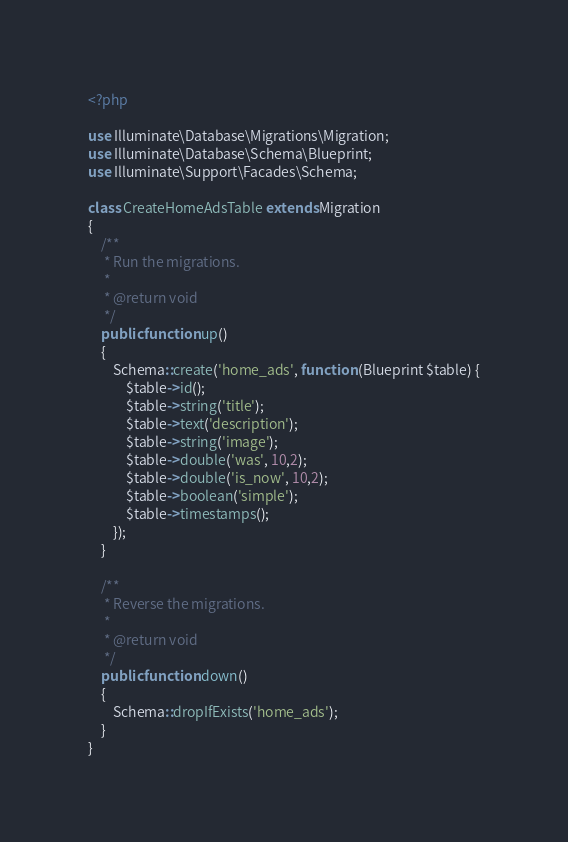Convert code to text. <code><loc_0><loc_0><loc_500><loc_500><_PHP_><?php

use Illuminate\Database\Migrations\Migration;
use Illuminate\Database\Schema\Blueprint;
use Illuminate\Support\Facades\Schema;

class CreateHomeAdsTable extends Migration
{
    /**
     * Run the migrations.
     *
     * @return void
     */
    public function up()
    {
        Schema::create('home_ads', function (Blueprint $table) {
            $table->id();
            $table->string('title');
            $table->text('description');
            $table->string('image');
            $table->double('was', 10,2);
            $table->double('is_now', 10,2);
            $table->boolean('simple');
            $table->timestamps();
        });
    }

    /**
     * Reverse the migrations.
     *
     * @return void
     */
    public function down()
    {
        Schema::dropIfExists('home_ads');
    }
}
</code> 